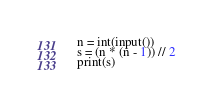Convert code to text. <code><loc_0><loc_0><loc_500><loc_500><_Python_>n = int(input())
s = (n * (n - 1)) // 2
print(s)</code> 